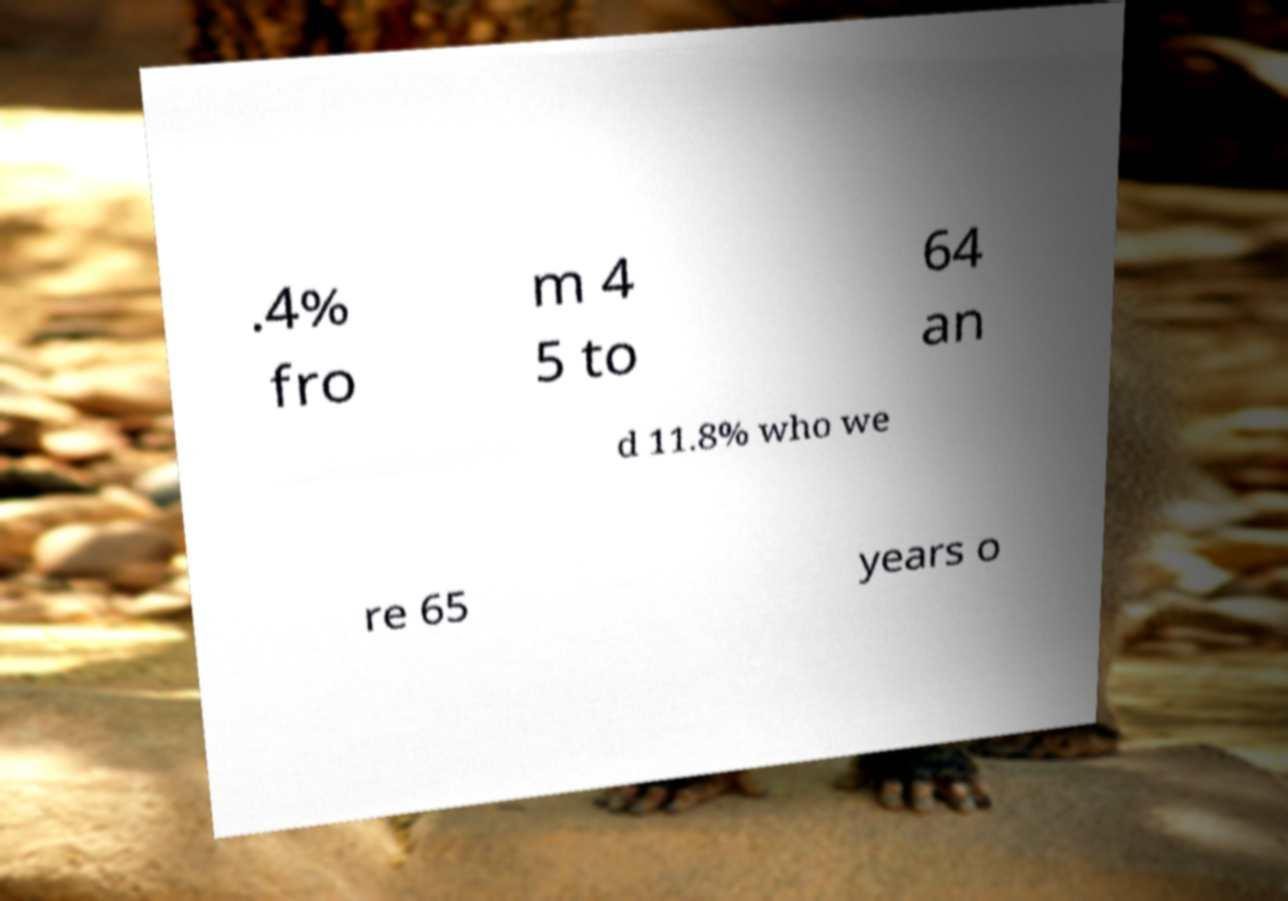Can you accurately transcribe the text from the provided image for me? .4% fro m 4 5 to 64 an d 11.8% who we re 65 years o 